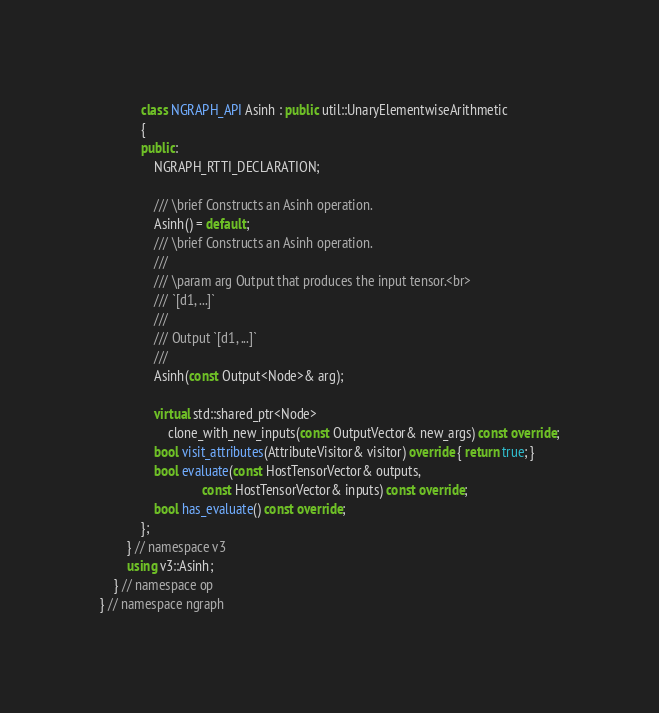Convert code to text. <code><loc_0><loc_0><loc_500><loc_500><_C++_>            class NGRAPH_API Asinh : public util::UnaryElementwiseArithmetic
            {
            public:
                NGRAPH_RTTI_DECLARATION;

                /// \brief Constructs an Asinh operation.
                Asinh() = default;
                /// \brief Constructs an Asinh operation.
                ///
                /// \param arg Output that produces the input tensor.<br>
                /// `[d1, ...]`
                ///
                /// Output `[d1, ...]`
                ///
                Asinh(const Output<Node>& arg);

                virtual std::shared_ptr<Node>
                    clone_with_new_inputs(const OutputVector& new_args) const override;
                bool visit_attributes(AttributeVisitor& visitor) override { return true; }
                bool evaluate(const HostTensorVector& outputs,
                              const HostTensorVector& inputs) const override;
                bool has_evaluate() const override;
            };
        } // namespace v3
        using v3::Asinh;
    } // namespace op
} // namespace ngraph
</code> 